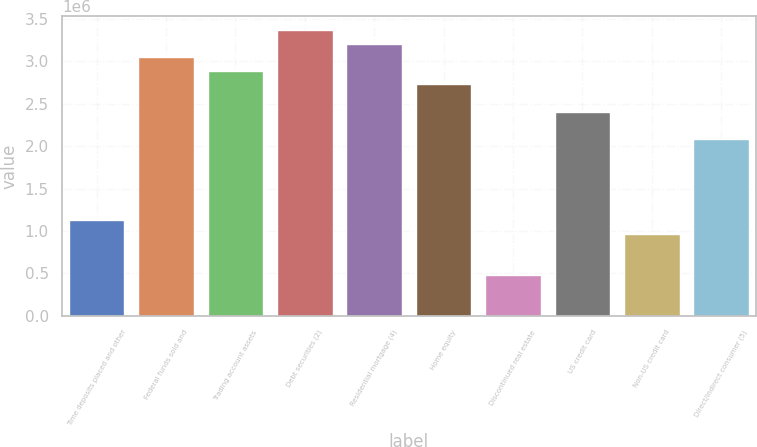<chart> <loc_0><loc_0><loc_500><loc_500><bar_chart><fcel>Time deposits placed and other<fcel>Federal funds sold and<fcel>Trading account assets<fcel>Debt securities (2)<fcel>Residential mortgage (4)<fcel>Home equity<fcel>Discontinued real estate<fcel>US credit card<fcel>Non-US credit card<fcel>Direct/Indirect consumer (5)<nl><fcel>1.12353e+06<fcel>3.04592e+06<fcel>2.88572e+06<fcel>3.36632e+06<fcel>3.20612e+06<fcel>2.72552e+06<fcel>482730<fcel>2.40512e+06<fcel>963328<fcel>2.08472e+06<nl></chart> 